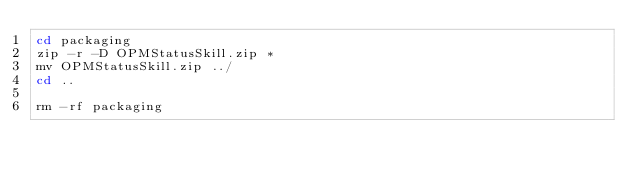<code> <loc_0><loc_0><loc_500><loc_500><_Bash_>cd packaging
zip -r -D OPMStatusSkill.zip *
mv OPMStatusSkill.zip ../
cd ..

rm -rf packaging
 
</code> 